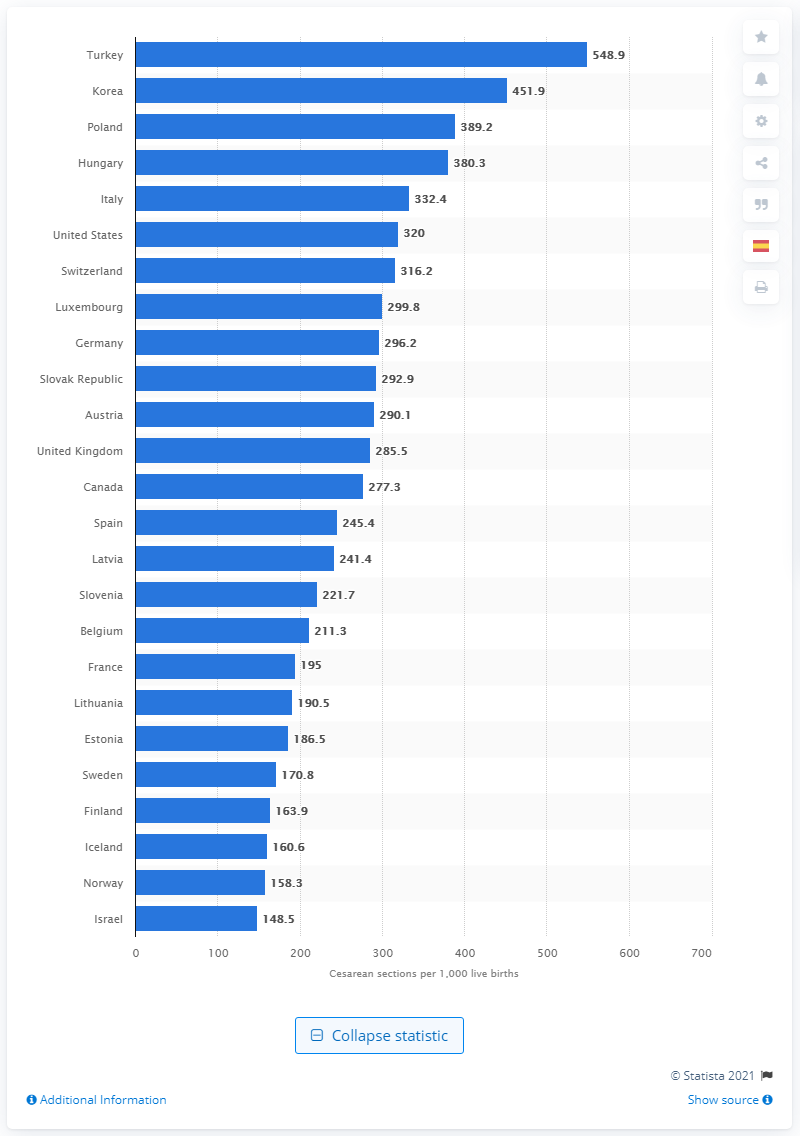Indicate a few pertinent items in this graphic. In 2018, Turkey had the highest rate of Caesarean section births among all countries. In 2018, the rate of C-sections per 1,000 live births in Turkey was 548.9. In 2018, the highest rate of C-section births occurred in Korea. 